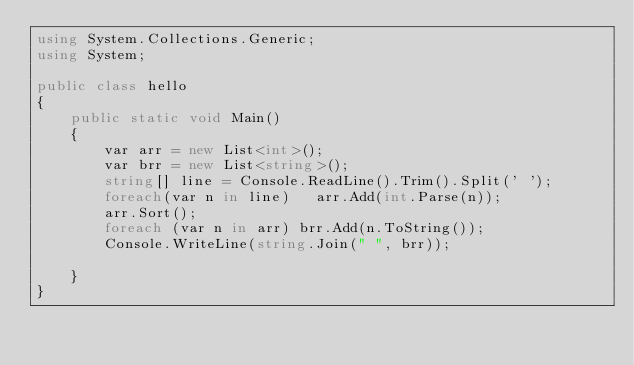<code> <loc_0><loc_0><loc_500><loc_500><_C#_>using System.Collections.Generic;
using System;

public class hello
{
    public static void Main()
    {
        var arr = new List<int>();
        var brr = new List<string>();
        string[] line = Console.ReadLine().Trim().Split(' ');
        foreach(var n in line)   arr.Add(int.Parse(n));
        arr.Sort();
        foreach (var n in arr) brr.Add(n.ToString());
        Console.WriteLine(string.Join(" ", brr)); 

    }
}</code> 